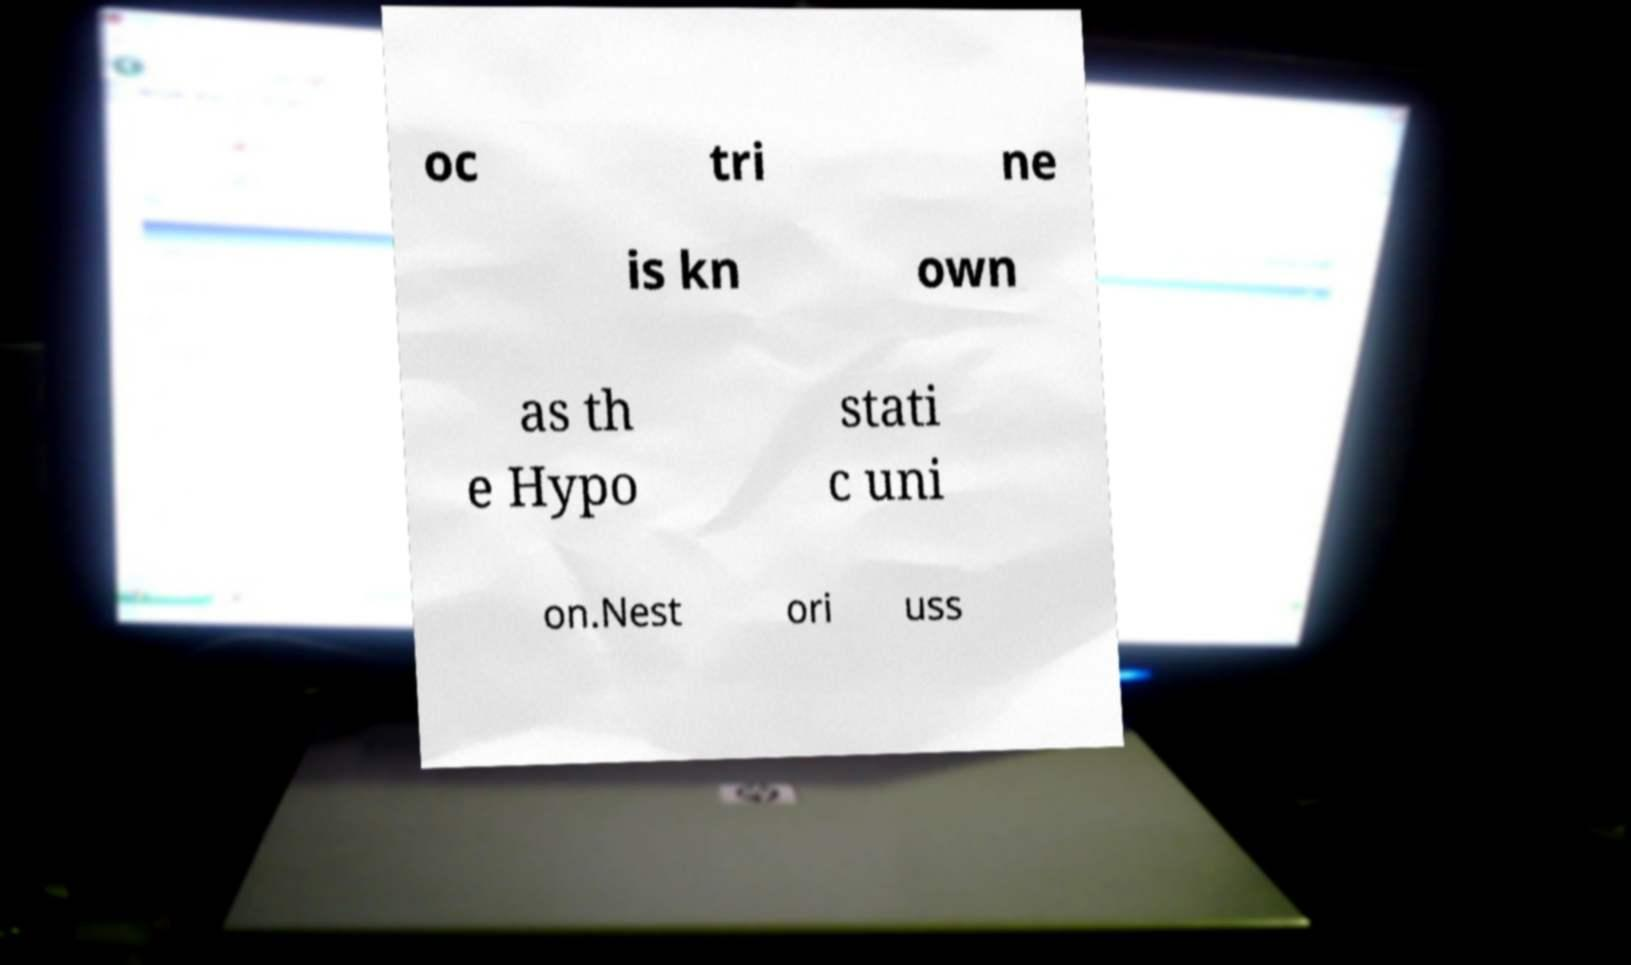Can you read and provide the text displayed in the image?This photo seems to have some interesting text. Can you extract and type it out for me? oc tri ne is kn own as th e Hypo stati c uni on.Nest ori uss 